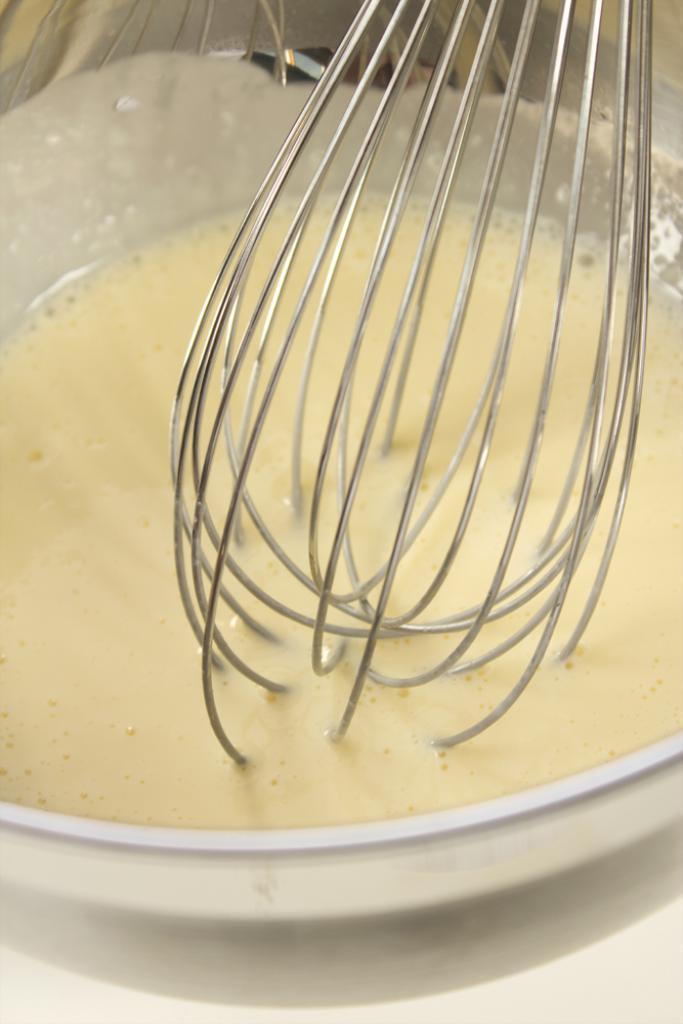What is the main object in the image? There is a whisking tool in the image. Where is the whisking tool located? The whisking tool is in a bowl. What is inside the bowl with the whisking tool? The bowl contains some liquid. How many cents are visible on the whisking tool in the image? There are no cents visible on the whisking tool in the image. What type of dress is being worn by the whisking tool in the image? The whisking tool is an inanimate object and does not wear clothing, such as a dress. 